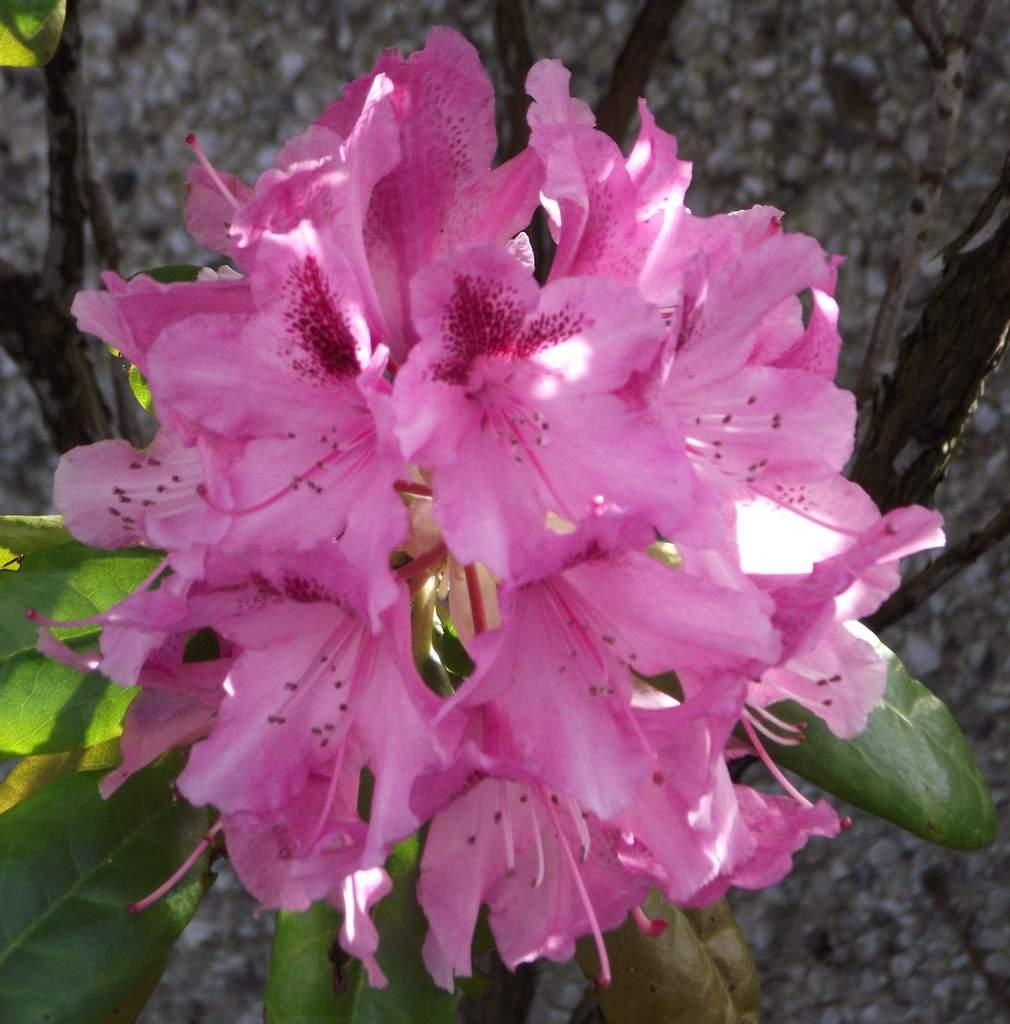What type of flowers can be seen on the plant in the image? There are pink flowers on a plant in the image. Can you describe the background of the image? The background of the image is blurred. Where is the faucet located in the image? There is no faucet present in the image. What type of ship can be seen in the image? There is no ship present in the image. 